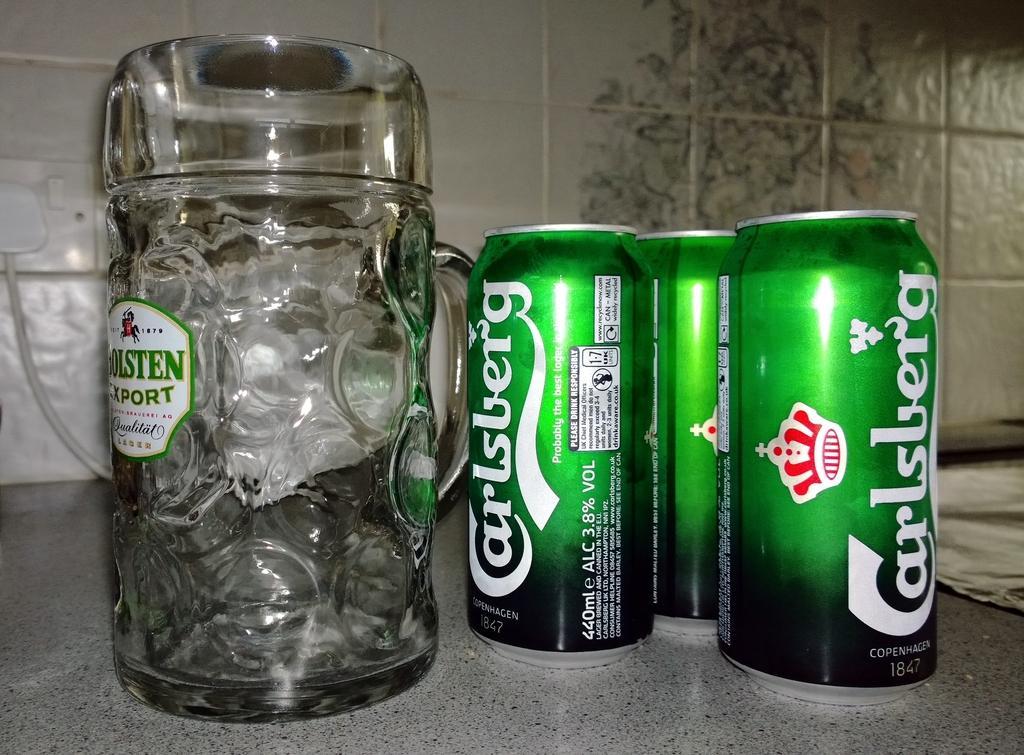Can you describe this image briefly? In the image there are coke tins and a glass kept on a marble floor and in the background there are tiles. 